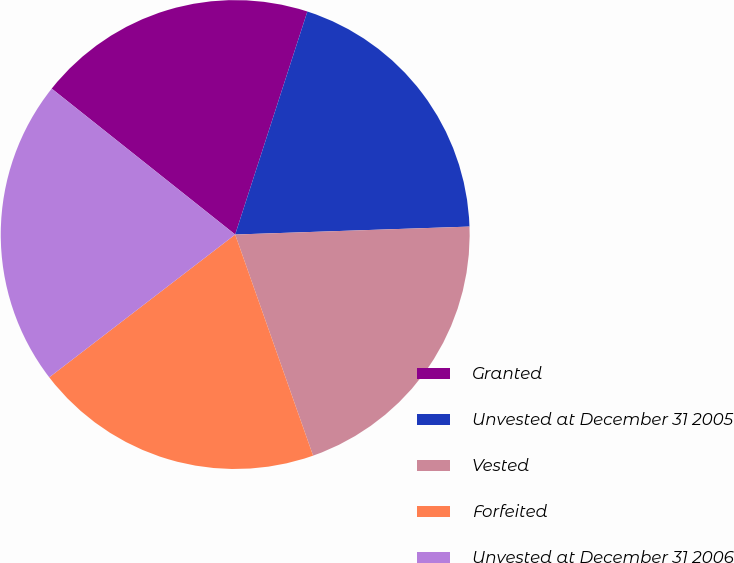Convert chart to OTSL. <chart><loc_0><loc_0><loc_500><loc_500><pie_chart><fcel>Granted<fcel>Unvested at December 31 2005<fcel>Vested<fcel>Forfeited<fcel>Unvested at December 31 2006<nl><fcel>19.29%<fcel>19.48%<fcel>20.15%<fcel>19.97%<fcel>21.12%<nl></chart> 